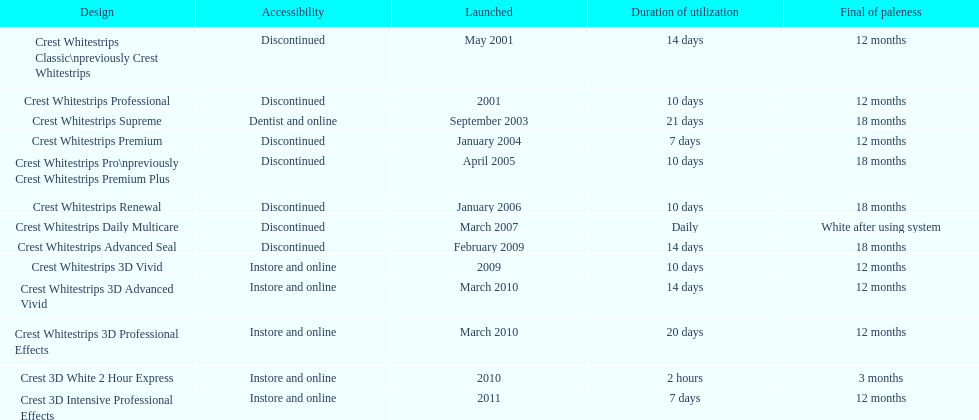Which product was to be used longer, crest whitestrips classic or crest whitestrips 3d vivid? Crest Whitestrips Classic. 